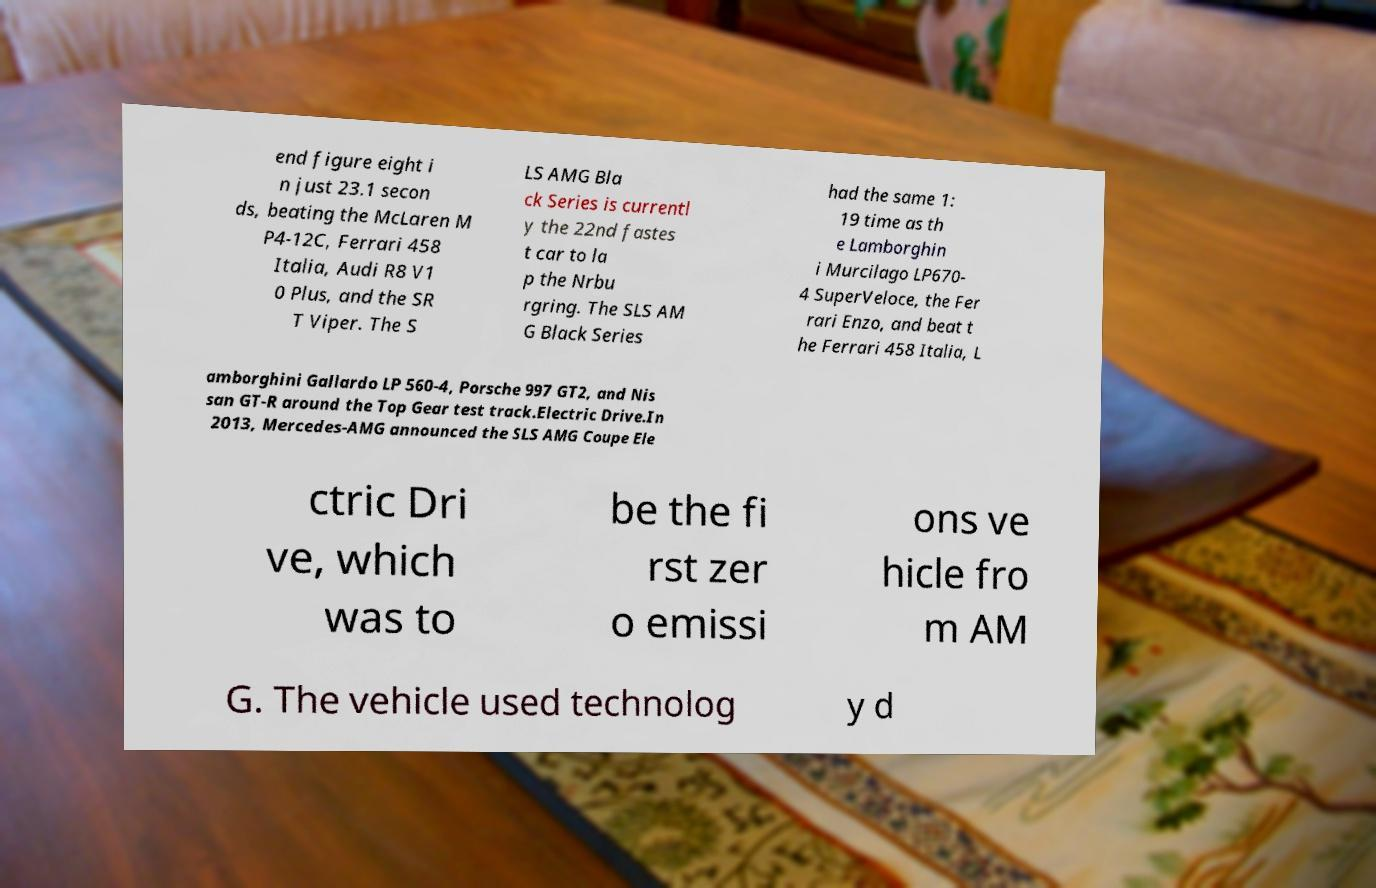Can you read and provide the text displayed in the image?This photo seems to have some interesting text. Can you extract and type it out for me? end figure eight i n just 23.1 secon ds, beating the McLaren M P4-12C, Ferrari 458 Italia, Audi R8 V1 0 Plus, and the SR T Viper. The S LS AMG Bla ck Series is currentl y the 22nd fastes t car to la p the Nrbu rgring. The SLS AM G Black Series had the same 1: 19 time as th e Lamborghin i Murcilago LP670- 4 SuperVeloce, the Fer rari Enzo, and beat t he Ferrari 458 Italia, L amborghini Gallardo LP 560-4, Porsche 997 GT2, and Nis san GT-R around the Top Gear test track.Electric Drive.In 2013, Mercedes-AMG announced the SLS AMG Coupe Ele ctric Dri ve, which was to be the fi rst zer o emissi ons ve hicle fro m AM G. The vehicle used technolog y d 